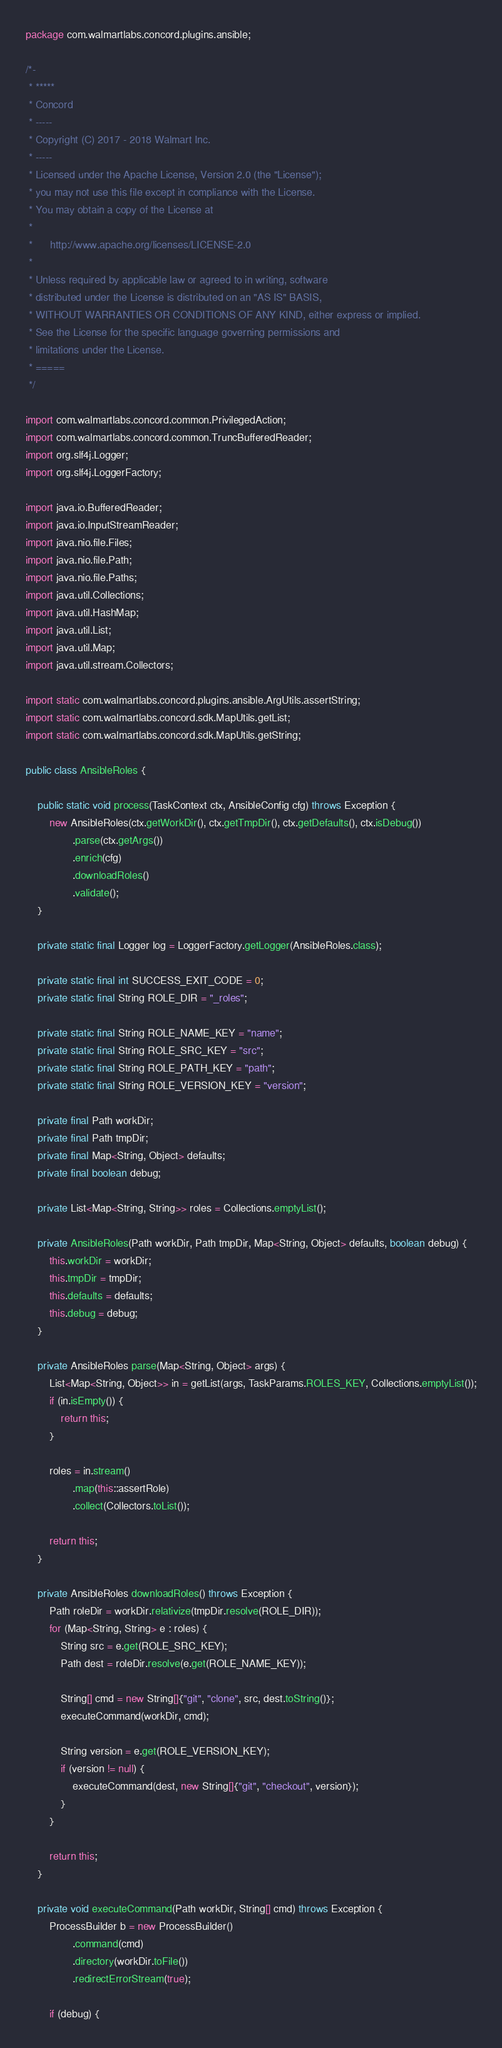<code> <loc_0><loc_0><loc_500><loc_500><_Java_>package com.walmartlabs.concord.plugins.ansible;

/*-
 * *****
 * Concord
 * -----
 * Copyright (C) 2017 - 2018 Walmart Inc.
 * -----
 * Licensed under the Apache License, Version 2.0 (the "License");
 * you may not use this file except in compliance with the License.
 * You may obtain a copy of the License at
 *
 *      http://www.apache.org/licenses/LICENSE-2.0
 *
 * Unless required by applicable law or agreed to in writing, software
 * distributed under the License is distributed on an "AS IS" BASIS,
 * WITHOUT WARRANTIES OR CONDITIONS OF ANY KIND, either express or implied.
 * See the License for the specific language governing permissions and
 * limitations under the License.
 * =====
 */

import com.walmartlabs.concord.common.PrivilegedAction;
import com.walmartlabs.concord.common.TruncBufferedReader;
import org.slf4j.Logger;
import org.slf4j.LoggerFactory;

import java.io.BufferedReader;
import java.io.InputStreamReader;
import java.nio.file.Files;
import java.nio.file.Path;
import java.nio.file.Paths;
import java.util.Collections;
import java.util.HashMap;
import java.util.List;
import java.util.Map;
import java.util.stream.Collectors;

import static com.walmartlabs.concord.plugins.ansible.ArgUtils.assertString;
import static com.walmartlabs.concord.sdk.MapUtils.getList;
import static com.walmartlabs.concord.sdk.MapUtils.getString;

public class AnsibleRoles {

    public static void process(TaskContext ctx, AnsibleConfig cfg) throws Exception {
        new AnsibleRoles(ctx.getWorkDir(), ctx.getTmpDir(), ctx.getDefaults(), ctx.isDebug())
                .parse(ctx.getArgs())
                .enrich(cfg)
                .downloadRoles()
                .validate();
    }

    private static final Logger log = LoggerFactory.getLogger(AnsibleRoles.class);

    private static final int SUCCESS_EXIT_CODE = 0;
    private static final String ROLE_DIR = "_roles";

    private static final String ROLE_NAME_KEY = "name";
    private static final String ROLE_SRC_KEY = "src";
    private static final String ROLE_PATH_KEY = "path";
    private static final String ROLE_VERSION_KEY = "version";

    private final Path workDir;
    private final Path tmpDir;
    private final Map<String, Object> defaults;
    private final boolean debug;

    private List<Map<String, String>> roles = Collections.emptyList();

    private AnsibleRoles(Path workDir, Path tmpDir, Map<String, Object> defaults, boolean debug) {
        this.workDir = workDir;
        this.tmpDir = tmpDir;
        this.defaults = defaults;
        this.debug = debug;
    }

    private AnsibleRoles parse(Map<String, Object> args) {
        List<Map<String, Object>> in = getList(args, TaskParams.ROLES_KEY, Collections.emptyList());
        if (in.isEmpty()) {
            return this;
        }

        roles = in.stream()
                .map(this::assertRole)
                .collect(Collectors.toList());

        return this;
    }

    private AnsibleRoles downloadRoles() throws Exception {
        Path roleDir = workDir.relativize(tmpDir.resolve(ROLE_DIR));
        for (Map<String, String> e : roles) {
            String src = e.get(ROLE_SRC_KEY);
            Path dest = roleDir.resolve(e.get(ROLE_NAME_KEY));

            String[] cmd = new String[]{"git", "clone", src, dest.toString()};
            executeCommand(workDir, cmd);

            String version = e.get(ROLE_VERSION_KEY);
            if (version != null) {
                executeCommand(dest, new String[]{"git", "checkout", version});
            }
        }

        return this;
    }

    private void executeCommand(Path workDir, String[] cmd) throws Exception {
        ProcessBuilder b = new ProcessBuilder()
                .command(cmd)
                .directory(workDir.toFile())
                .redirectErrorStream(true);

        if (debug) {</code> 